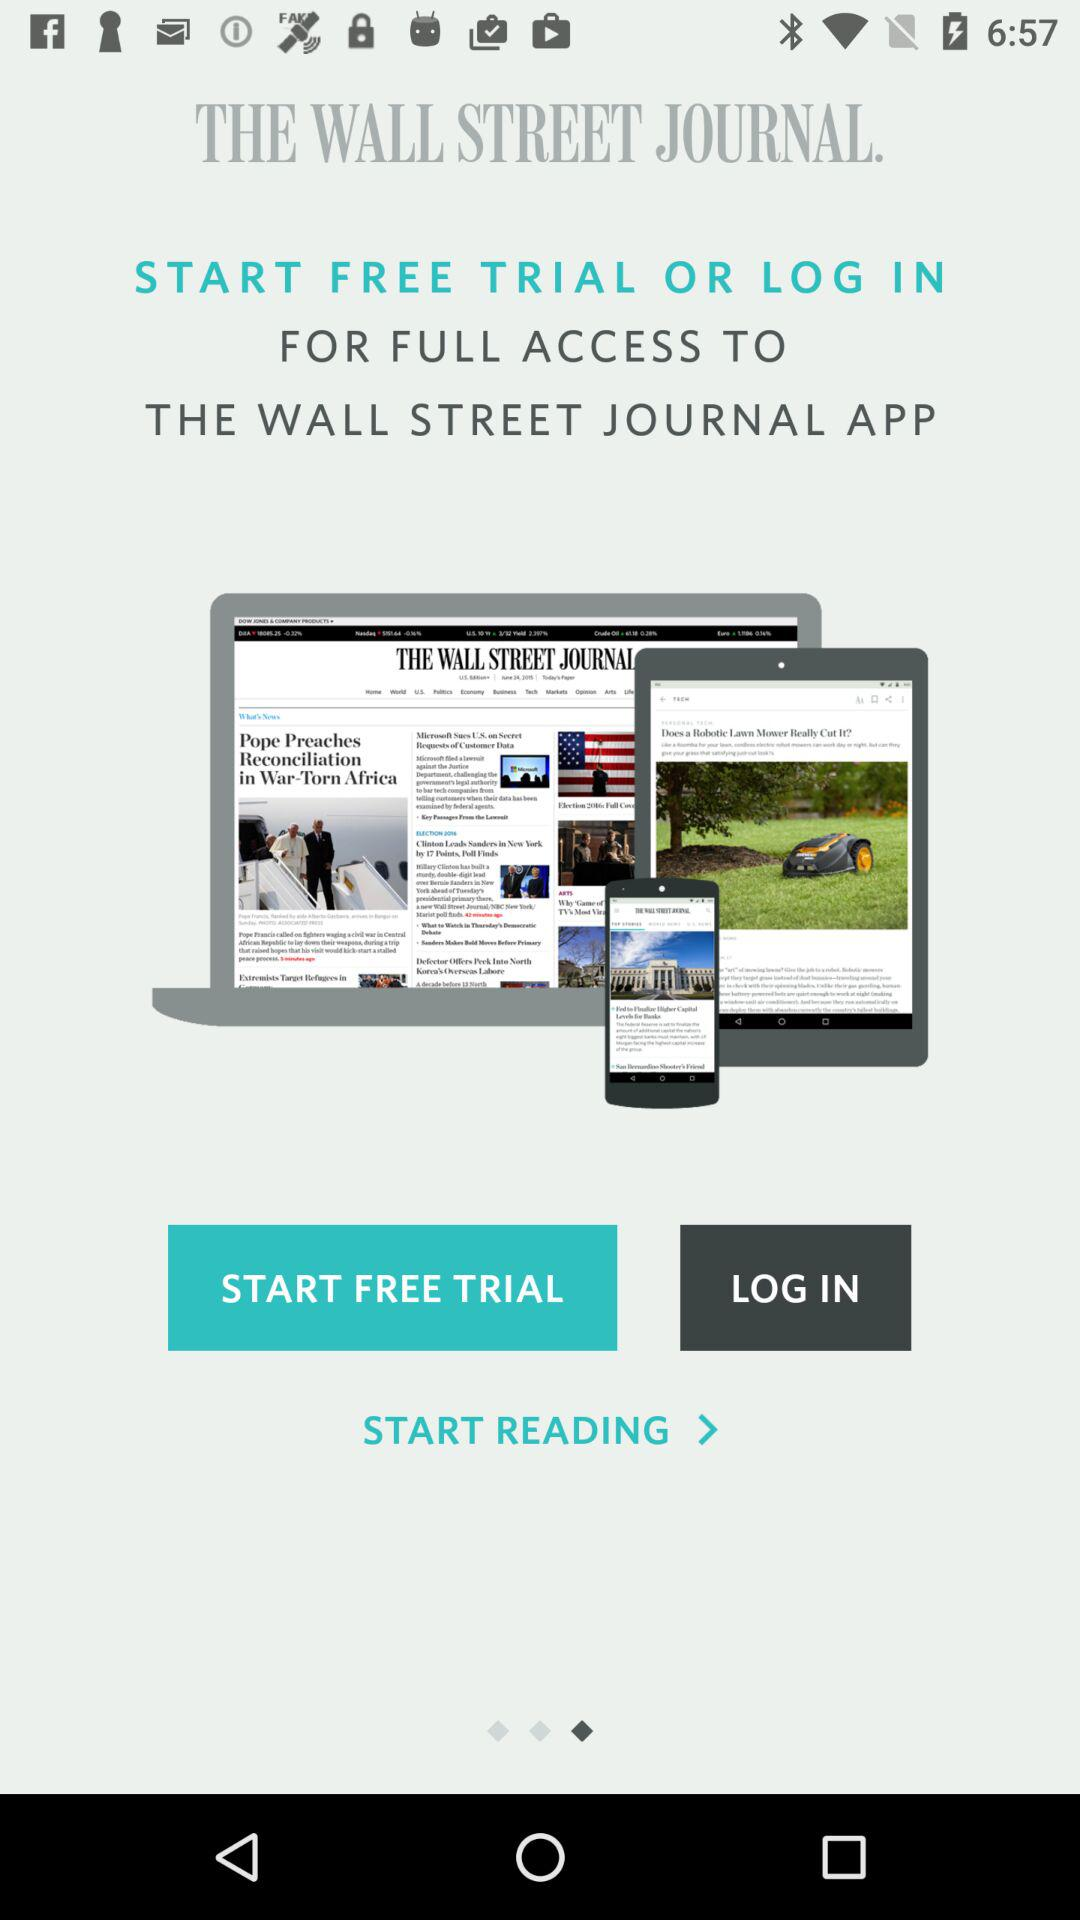How do you start reading?
When the provided information is insufficient, respond with <no answer>. <no answer> 